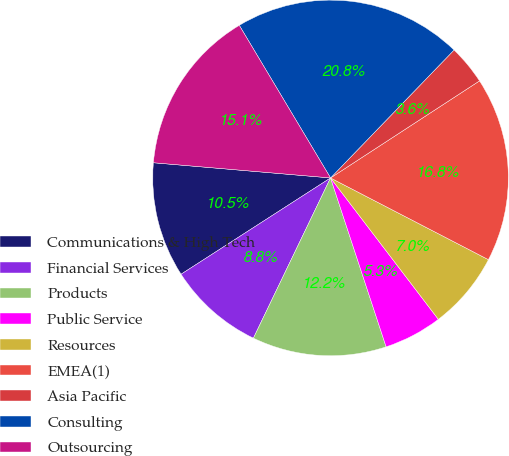<chart> <loc_0><loc_0><loc_500><loc_500><pie_chart><fcel>Communications & High Tech<fcel>Financial Services<fcel>Products<fcel>Public Service<fcel>Resources<fcel>EMEA(1)<fcel>Asia Pacific<fcel>Consulting<fcel>Outsourcing<nl><fcel>10.47%<fcel>8.75%<fcel>12.2%<fcel>5.31%<fcel>7.03%<fcel>16.79%<fcel>3.59%<fcel>20.8%<fcel>15.06%<nl></chart> 